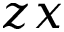<formula> <loc_0><loc_0><loc_500><loc_500>z x</formula> 